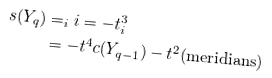<formula> <loc_0><loc_0><loc_500><loc_500>s ( Y _ { q } ) & = _ { i } i = - t ^ { 3 } _ { i } \\ & = - t ^ { 4 } c ( Y _ { q - 1 } ) - t ^ { 2 } ( \text {meridians} )</formula> 